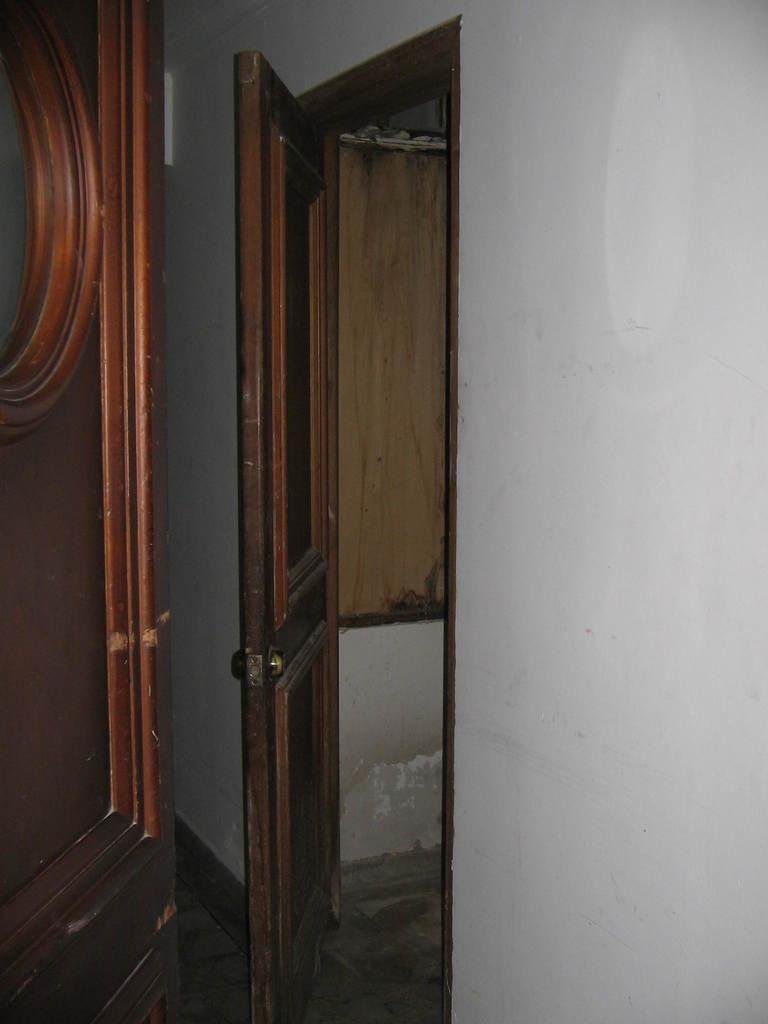What is one of the main structures visible in the image? There is a door in the image. What other architectural element can be seen in the image? There is a wall in the image. Can you describe the door's location in relation to the wall? The door is likely part of the wall, as it is a common architectural feature. How many mice can be seen running on the wall in the image? There are no mice visible in the image. What is the position of the door in relation to the cent of the wall? The position of the door in relation to the cent of the wall cannot be determined from the image, as there is no reference point for the center of the wall. 